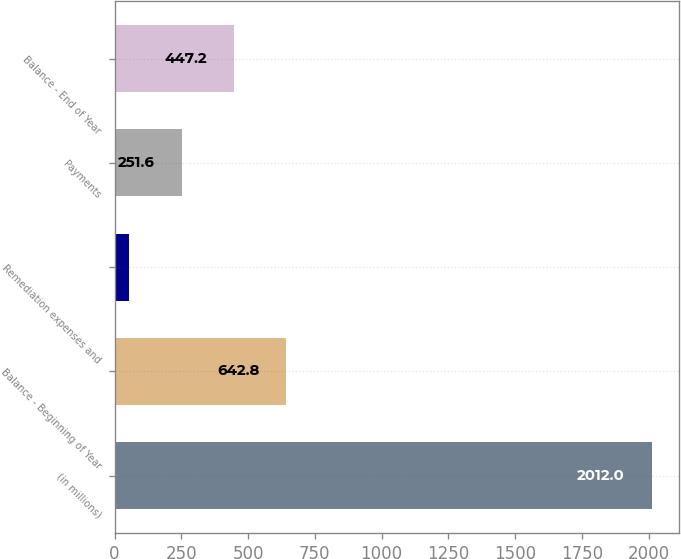Convert chart to OTSL. <chart><loc_0><loc_0><loc_500><loc_500><bar_chart><fcel>(in millions)<fcel>Balance - Beginning of Year<fcel>Remediation expenses and<fcel>Payments<fcel>Balance - End of Year<nl><fcel>2012<fcel>642.8<fcel>56<fcel>251.6<fcel>447.2<nl></chart> 